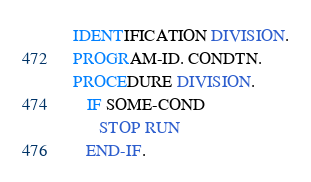Convert code to text. <code><loc_0><loc_0><loc_500><loc_500><_COBOL_> IDENTIFICATION DIVISION.
 PROGRAM-ID. CONDTN.
 PROCEDURE DIVISION.
    IF SOME-COND
       STOP RUN
    END-IF.</code> 